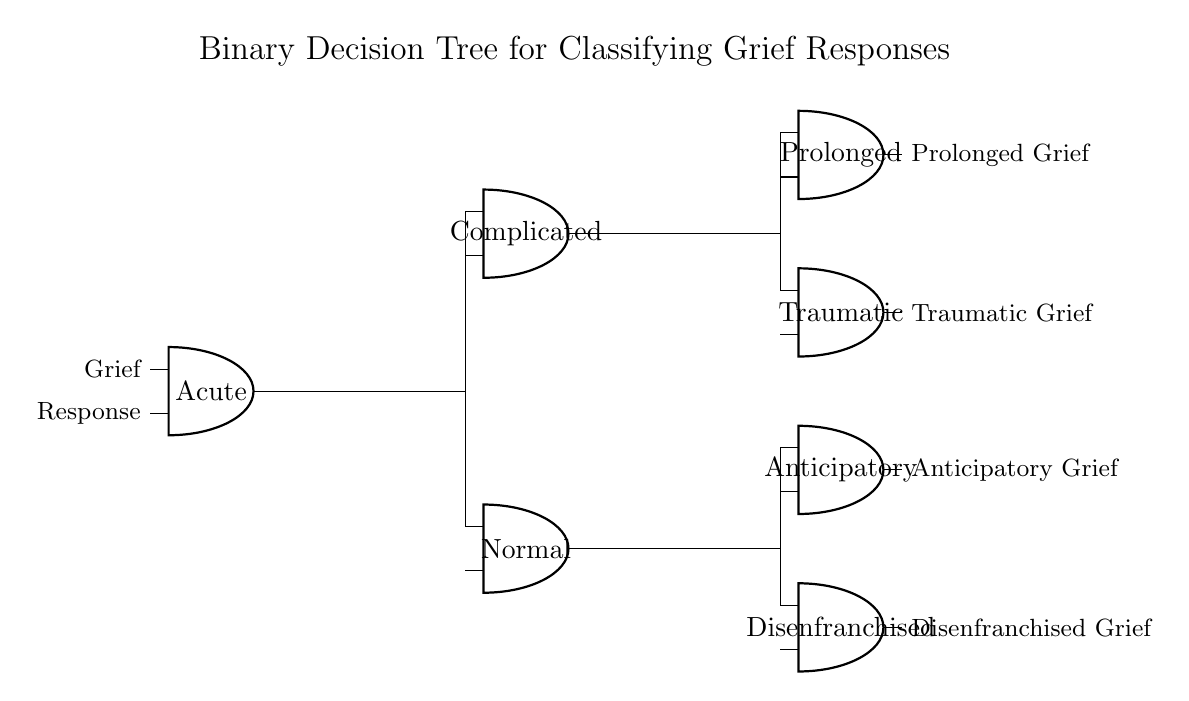What is the title of the circuit? The title is displayed at the top of the circuit diagram and indicates the purpose of the circuit. It reads "Binary Decision Tree for Classifying Grief Responses."
Answer: Binary Decision Tree for Classifying Grief Responses How many decision nodes are there in the circuit? By counting the 'and' ports in the diagram, we can see there are five decision nodes: one for acute grief, two for complicated grief, and two for normal grief responses.
Answer: Five What types of grief are classified as output from the circuit? The outputs can be seen on the right side of the circuit diagram, showing the types of grief: Prolonged, Traumatic, Anticipatory, and Disenfranchised.
Answer: Four types Which node classifies prolonged grief? Tracing from the decision node for complicated grief, we find that it connects to the node that specifies prolonged grief. This indicates that prolonged grief is classified under the complicated grief category.
Answer: Complicated Which type of grief is associated with the acute decision node? By following the connections from the acute decision node, we see that acute grief leads to outputs related to both complicated and normal grief responses. The output types classified under acute are thus the next layer of decision nodes.
Answer: Complicated and Normal What are the two grief responses linked to normal grief? Instantiating the connections from the normal grief decision node, it can be observed that both anticipatory and disenfranchised grief are linked to this node as outputs.
Answer: Anticipatory and Disenfranchised Is there a direct connection between acute grief and traumatic grief? There is no direct connection between acute grief and traumatic grief in the diagram; acute grief branches to other nodes, leading to complicated and normal grief without any direct output indicating traumatic grief.
Answer: No 